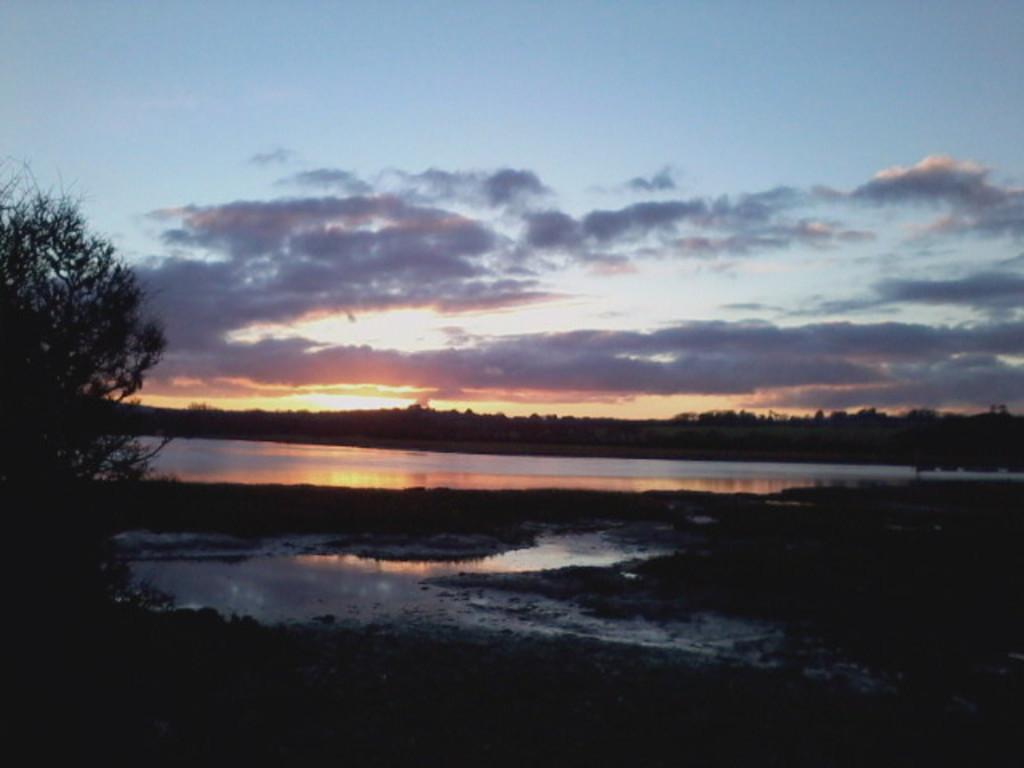Describe this image in one or two sentences. This image is taken during the evening time. In this image we can see the trees. We can also see the water. Sky is also visible with the clouds. We can also see the sun. 